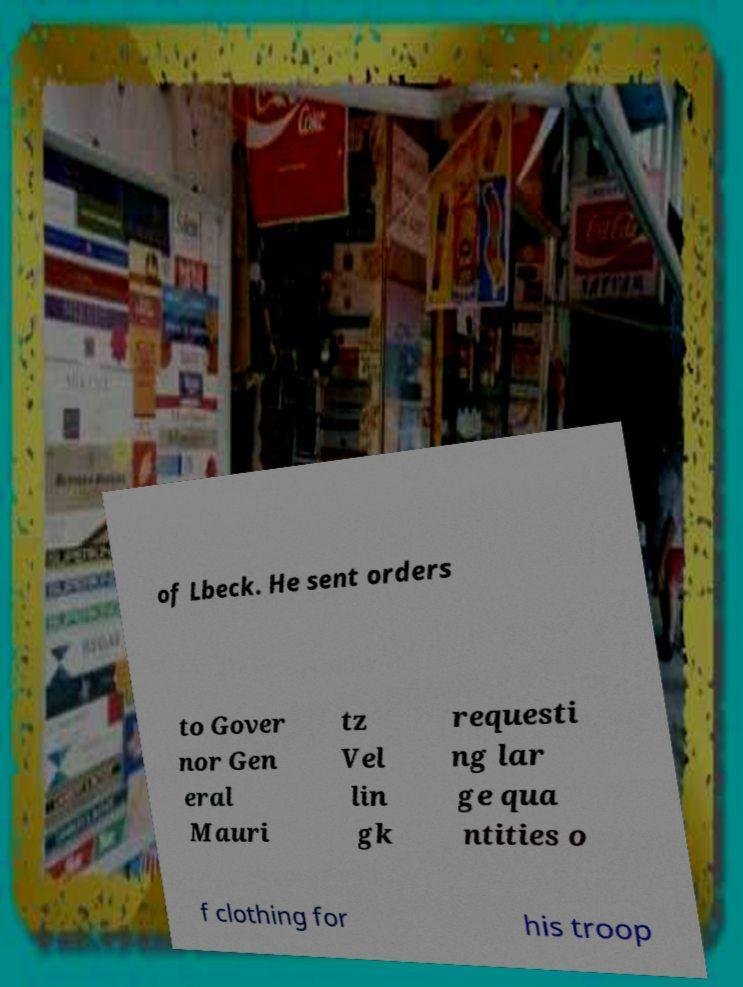There's text embedded in this image that I need extracted. Can you transcribe it verbatim? of Lbeck. He sent orders to Gover nor Gen eral Mauri tz Vel lin gk requesti ng lar ge qua ntities o f clothing for his troop 